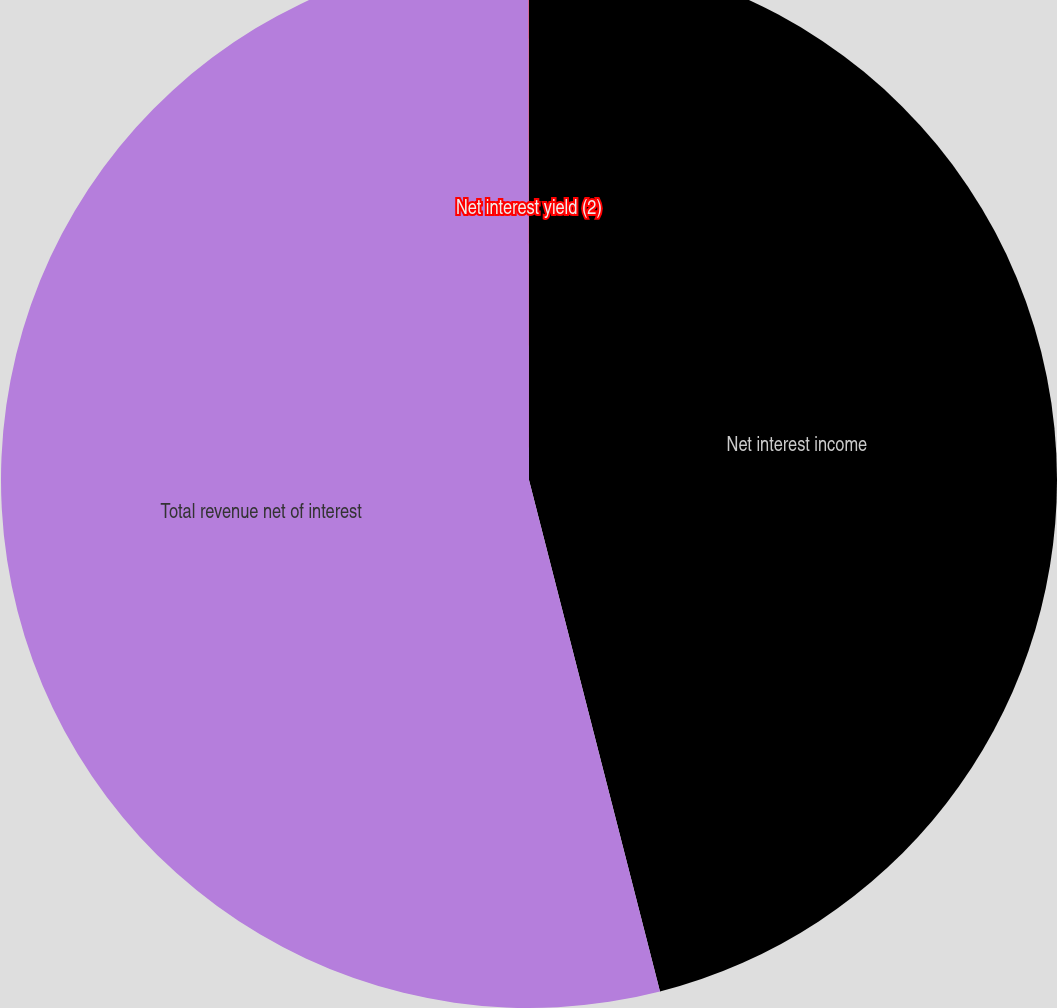Convert chart to OTSL. <chart><loc_0><loc_0><loc_500><loc_500><pie_chart><fcel>Net interest income<fcel>Total revenue net of interest<fcel>Net interest yield (2)<nl><fcel>46.01%<fcel>53.98%<fcel>0.01%<nl></chart> 